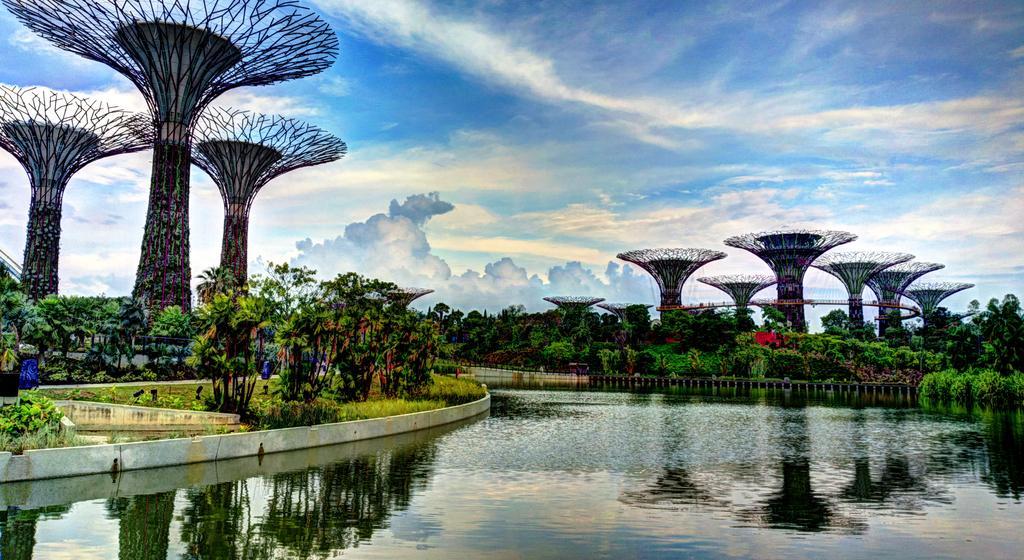Can you describe this image briefly? In this image there are trees, plants, water, cloudy sky, architecture and objects.   